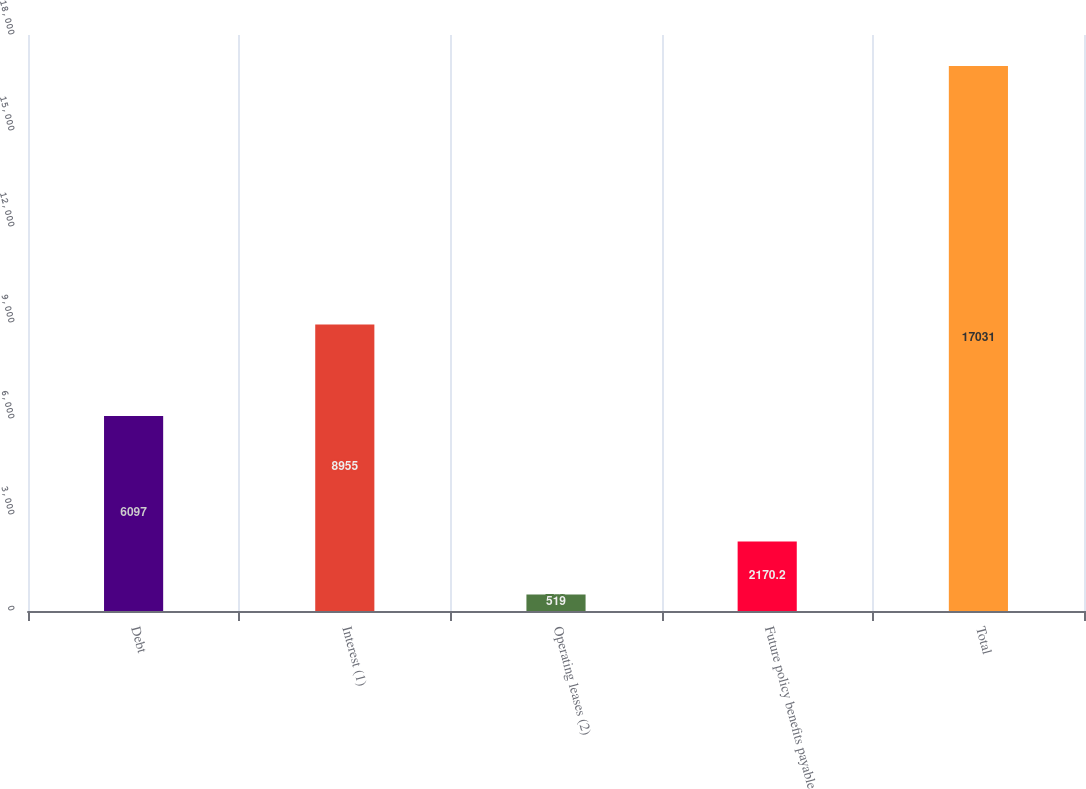<chart> <loc_0><loc_0><loc_500><loc_500><bar_chart><fcel>Debt<fcel>Interest (1)<fcel>Operating leases (2)<fcel>Future policy benefits payable<fcel>Total<nl><fcel>6097<fcel>8955<fcel>519<fcel>2170.2<fcel>17031<nl></chart> 